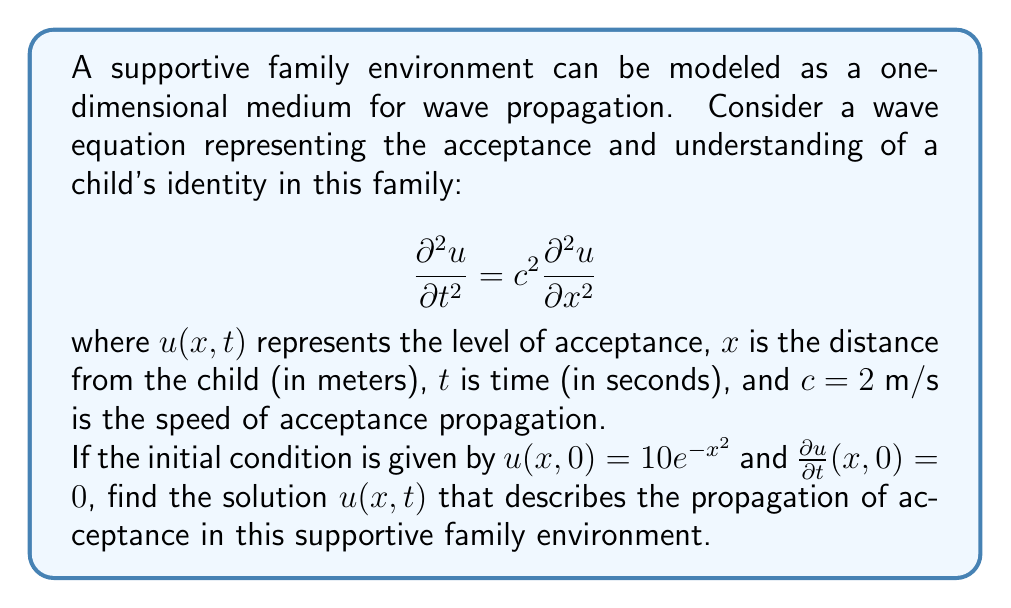Help me with this question. To solve this wave equation with the given initial conditions, we can use D'Alembert's solution:

1) D'Alembert's solution for the 1D wave equation is:
   $$u(x,t) = \frac{1}{2}[f(x+ct) + f(x-ct)] + \frac{1}{2c}\int_{x-ct}^{x+ct} g(s) ds$$
   where $f(x) = u(x,0)$ and $g(x) = \frac{\partial u}{\partial t}(x,0)$

2) In this case, $f(x) = 10e^{-x^2}$ and $g(x) = 0$

3) Substituting these into D'Alembert's solution:
   $$u(x,t) = \frac{1}{2}[10e^{-(x+ct)^2} + 10e^{-(x-ct)^2}] + 0$$

4) Simplifying:
   $$u(x,t) = 5e^{-(x+ct)^2} + 5e^{-(x-ct)^2}$$

5) This is the final solution representing the propagation of acceptance in the family environment.
Answer: $u(x,t) = 5e^{-(x+ct)^2} + 5e^{-(x-ct)^2}$ 